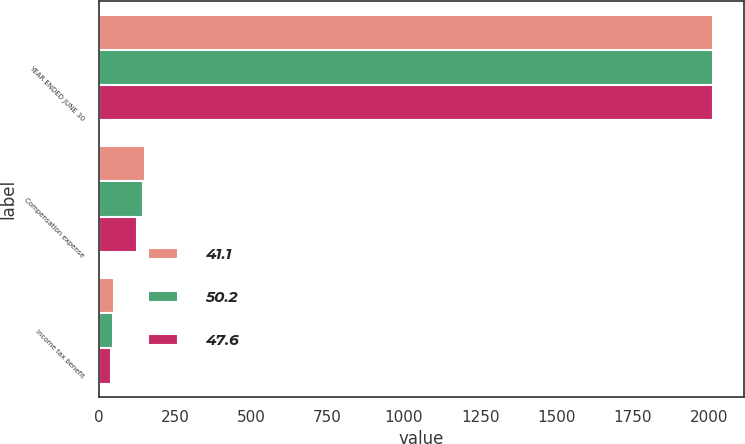Convert chart. <chart><loc_0><loc_0><loc_500><loc_500><stacked_bar_chart><ecel><fcel>YEAR ENDED JUNE 30<fcel>Compensation expense<fcel>Income tax benefit<nl><fcel>41.1<fcel>2014<fcel>152.6<fcel>50.2<nl><fcel>50.2<fcel>2013<fcel>145.8<fcel>47.6<nl><fcel>47.6<fcel>2012<fcel>124.7<fcel>41.1<nl></chart> 